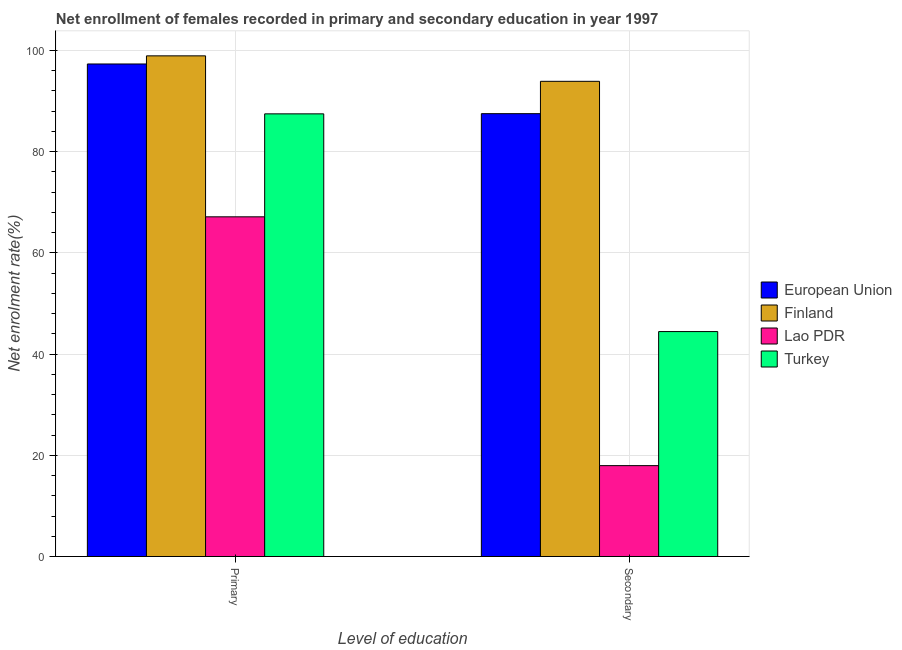How many different coloured bars are there?
Provide a succinct answer. 4. Are the number of bars per tick equal to the number of legend labels?
Your response must be concise. Yes. How many bars are there on the 2nd tick from the left?
Your answer should be very brief. 4. How many bars are there on the 2nd tick from the right?
Give a very brief answer. 4. What is the label of the 2nd group of bars from the left?
Make the answer very short. Secondary. What is the enrollment rate in secondary education in Finland?
Offer a very short reply. 93.88. Across all countries, what is the maximum enrollment rate in secondary education?
Your answer should be very brief. 93.88. Across all countries, what is the minimum enrollment rate in primary education?
Provide a succinct answer. 67.11. In which country was the enrollment rate in secondary education minimum?
Your answer should be very brief. Lao PDR. What is the total enrollment rate in secondary education in the graph?
Offer a very short reply. 243.78. What is the difference between the enrollment rate in secondary education in Finland and that in Lao PDR?
Your answer should be very brief. 75.93. What is the difference between the enrollment rate in primary education in European Union and the enrollment rate in secondary education in Lao PDR?
Keep it short and to the point. 79.35. What is the average enrollment rate in secondary education per country?
Offer a terse response. 60.94. What is the difference between the enrollment rate in secondary education and enrollment rate in primary education in European Union?
Make the answer very short. -9.82. In how many countries, is the enrollment rate in secondary education greater than 84 %?
Give a very brief answer. 2. What is the ratio of the enrollment rate in secondary education in Lao PDR to that in Turkey?
Your answer should be compact. 0.4. In how many countries, is the enrollment rate in primary education greater than the average enrollment rate in primary education taken over all countries?
Provide a short and direct response. 2. What does the 1st bar from the left in Primary represents?
Make the answer very short. European Union. Are the values on the major ticks of Y-axis written in scientific E-notation?
Offer a terse response. No. Does the graph contain any zero values?
Provide a succinct answer. No. Does the graph contain grids?
Give a very brief answer. Yes. What is the title of the graph?
Keep it short and to the point. Net enrollment of females recorded in primary and secondary education in year 1997. Does "Israel" appear as one of the legend labels in the graph?
Offer a terse response. No. What is the label or title of the X-axis?
Provide a succinct answer. Level of education. What is the label or title of the Y-axis?
Provide a succinct answer. Net enrolment rate(%). What is the Net enrolment rate(%) in European Union in Primary?
Offer a terse response. 97.31. What is the Net enrolment rate(%) in Finland in Primary?
Provide a short and direct response. 98.91. What is the Net enrolment rate(%) in Lao PDR in Primary?
Provide a short and direct response. 67.11. What is the Net enrolment rate(%) of Turkey in Primary?
Your response must be concise. 87.46. What is the Net enrolment rate(%) in European Union in Secondary?
Offer a terse response. 87.49. What is the Net enrolment rate(%) of Finland in Secondary?
Keep it short and to the point. 93.88. What is the Net enrolment rate(%) of Lao PDR in Secondary?
Your answer should be compact. 17.96. What is the Net enrolment rate(%) in Turkey in Secondary?
Give a very brief answer. 44.44. Across all Level of education, what is the maximum Net enrolment rate(%) in European Union?
Provide a short and direct response. 97.31. Across all Level of education, what is the maximum Net enrolment rate(%) of Finland?
Your response must be concise. 98.91. Across all Level of education, what is the maximum Net enrolment rate(%) in Lao PDR?
Offer a terse response. 67.11. Across all Level of education, what is the maximum Net enrolment rate(%) in Turkey?
Offer a very short reply. 87.46. Across all Level of education, what is the minimum Net enrolment rate(%) of European Union?
Give a very brief answer. 87.49. Across all Level of education, what is the minimum Net enrolment rate(%) of Finland?
Make the answer very short. 93.88. Across all Level of education, what is the minimum Net enrolment rate(%) in Lao PDR?
Ensure brevity in your answer.  17.96. Across all Level of education, what is the minimum Net enrolment rate(%) in Turkey?
Keep it short and to the point. 44.44. What is the total Net enrolment rate(%) of European Union in the graph?
Your answer should be very brief. 184.8. What is the total Net enrolment rate(%) of Finland in the graph?
Your answer should be very brief. 192.8. What is the total Net enrolment rate(%) of Lao PDR in the graph?
Your answer should be compact. 85.07. What is the total Net enrolment rate(%) of Turkey in the graph?
Make the answer very short. 131.9. What is the difference between the Net enrolment rate(%) of European Union in Primary and that in Secondary?
Provide a succinct answer. 9.82. What is the difference between the Net enrolment rate(%) of Finland in Primary and that in Secondary?
Ensure brevity in your answer.  5.03. What is the difference between the Net enrolment rate(%) in Lao PDR in Primary and that in Secondary?
Your answer should be compact. 49.16. What is the difference between the Net enrolment rate(%) in Turkey in Primary and that in Secondary?
Make the answer very short. 43.01. What is the difference between the Net enrolment rate(%) in European Union in Primary and the Net enrolment rate(%) in Finland in Secondary?
Offer a very short reply. 3.43. What is the difference between the Net enrolment rate(%) of European Union in Primary and the Net enrolment rate(%) of Lao PDR in Secondary?
Ensure brevity in your answer.  79.35. What is the difference between the Net enrolment rate(%) in European Union in Primary and the Net enrolment rate(%) in Turkey in Secondary?
Your answer should be compact. 52.87. What is the difference between the Net enrolment rate(%) in Finland in Primary and the Net enrolment rate(%) in Lao PDR in Secondary?
Your answer should be compact. 80.96. What is the difference between the Net enrolment rate(%) in Finland in Primary and the Net enrolment rate(%) in Turkey in Secondary?
Offer a terse response. 54.47. What is the difference between the Net enrolment rate(%) of Lao PDR in Primary and the Net enrolment rate(%) of Turkey in Secondary?
Provide a short and direct response. 22.67. What is the average Net enrolment rate(%) in European Union per Level of education?
Provide a succinct answer. 92.4. What is the average Net enrolment rate(%) of Finland per Level of education?
Make the answer very short. 96.4. What is the average Net enrolment rate(%) in Lao PDR per Level of education?
Ensure brevity in your answer.  42.53. What is the average Net enrolment rate(%) of Turkey per Level of education?
Offer a very short reply. 65.95. What is the difference between the Net enrolment rate(%) in European Union and Net enrolment rate(%) in Finland in Primary?
Give a very brief answer. -1.6. What is the difference between the Net enrolment rate(%) in European Union and Net enrolment rate(%) in Lao PDR in Primary?
Your response must be concise. 30.2. What is the difference between the Net enrolment rate(%) in European Union and Net enrolment rate(%) in Turkey in Primary?
Your answer should be very brief. 9.85. What is the difference between the Net enrolment rate(%) of Finland and Net enrolment rate(%) of Lao PDR in Primary?
Make the answer very short. 31.8. What is the difference between the Net enrolment rate(%) in Finland and Net enrolment rate(%) in Turkey in Primary?
Offer a very short reply. 11.46. What is the difference between the Net enrolment rate(%) in Lao PDR and Net enrolment rate(%) in Turkey in Primary?
Give a very brief answer. -20.34. What is the difference between the Net enrolment rate(%) in European Union and Net enrolment rate(%) in Finland in Secondary?
Your response must be concise. -6.39. What is the difference between the Net enrolment rate(%) of European Union and Net enrolment rate(%) of Lao PDR in Secondary?
Give a very brief answer. 69.54. What is the difference between the Net enrolment rate(%) in European Union and Net enrolment rate(%) in Turkey in Secondary?
Provide a short and direct response. 43.05. What is the difference between the Net enrolment rate(%) in Finland and Net enrolment rate(%) in Lao PDR in Secondary?
Your answer should be compact. 75.93. What is the difference between the Net enrolment rate(%) in Finland and Net enrolment rate(%) in Turkey in Secondary?
Ensure brevity in your answer.  49.44. What is the difference between the Net enrolment rate(%) of Lao PDR and Net enrolment rate(%) of Turkey in Secondary?
Provide a short and direct response. -26.49. What is the ratio of the Net enrolment rate(%) of European Union in Primary to that in Secondary?
Provide a succinct answer. 1.11. What is the ratio of the Net enrolment rate(%) in Finland in Primary to that in Secondary?
Provide a short and direct response. 1.05. What is the ratio of the Net enrolment rate(%) in Lao PDR in Primary to that in Secondary?
Make the answer very short. 3.74. What is the ratio of the Net enrolment rate(%) of Turkey in Primary to that in Secondary?
Give a very brief answer. 1.97. What is the difference between the highest and the second highest Net enrolment rate(%) of European Union?
Provide a short and direct response. 9.82. What is the difference between the highest and the second highest Net enrolment rate(%) of Finland?
Ensure brevity in your answer.  5.03. What is the difference between the highest and the second highest Net enrolment rate(%) in Lao PDR?
Provide a short and direct response. 49.16. What is the difference between the highest and the second highest Net enrolment rate(%) of Turkey?
Make the answer very short. 43.01. What is the difference between the highest and the lowest Net enrolment rate(%) of European Union?
Give a very brief answer. 9.82. What is the difference between the highest and the lowest Net enrolment rate(%) of Finland?
Offer a very short reply. 5.03. What is the difference between the highest and the lowest Net enrolment rate(%) in Lao PDR?
Your answer should be very brief. 49.16. What is the difference between the highest and the lowest Net enrolment rate(%) in Turkey?
Give a very brief answer. 43.01. 